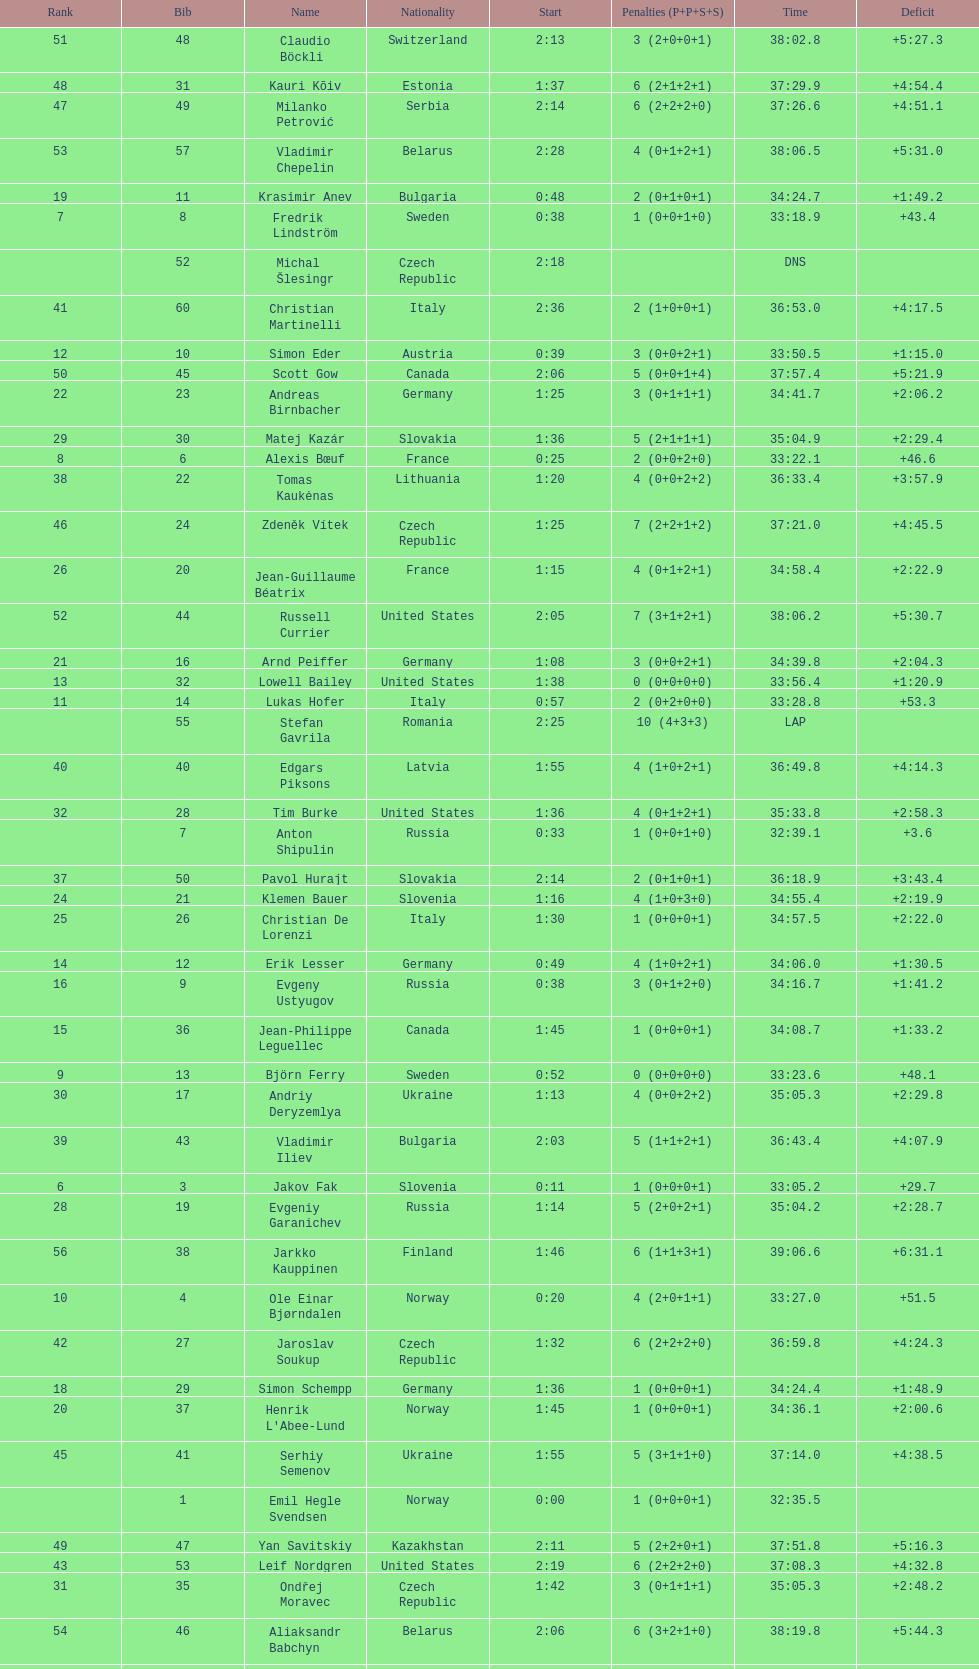How many united states competitors did not win medals? 4. 